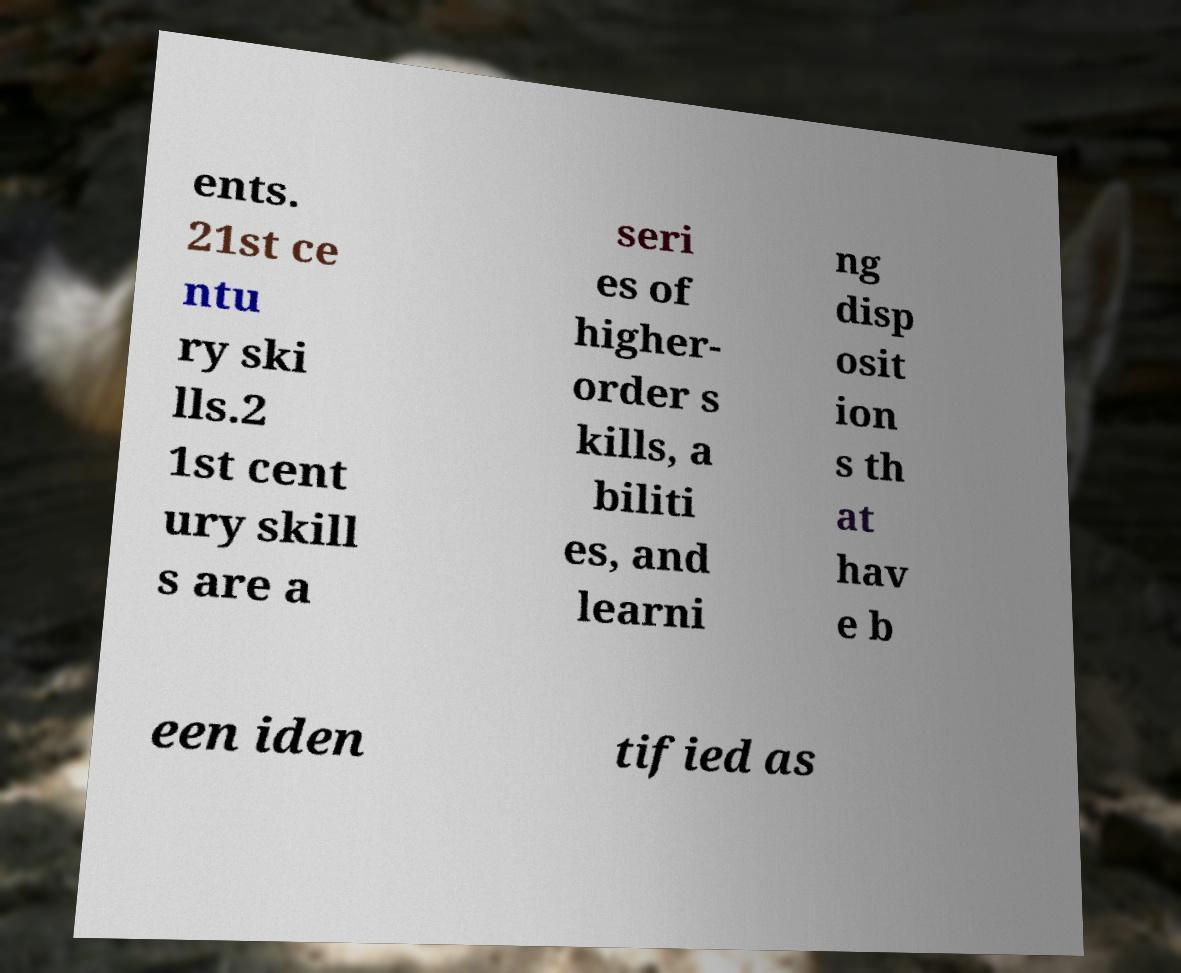For documentation purposes, I need the text within this image transcribed. Could you provide that? ents. 21st ce ntu ry ski lls.2 1st cent ury skill s are a seri es of higher- order s kills, a biliti es, and learni ng disp osit ion s th at hav e b een iden tified as 